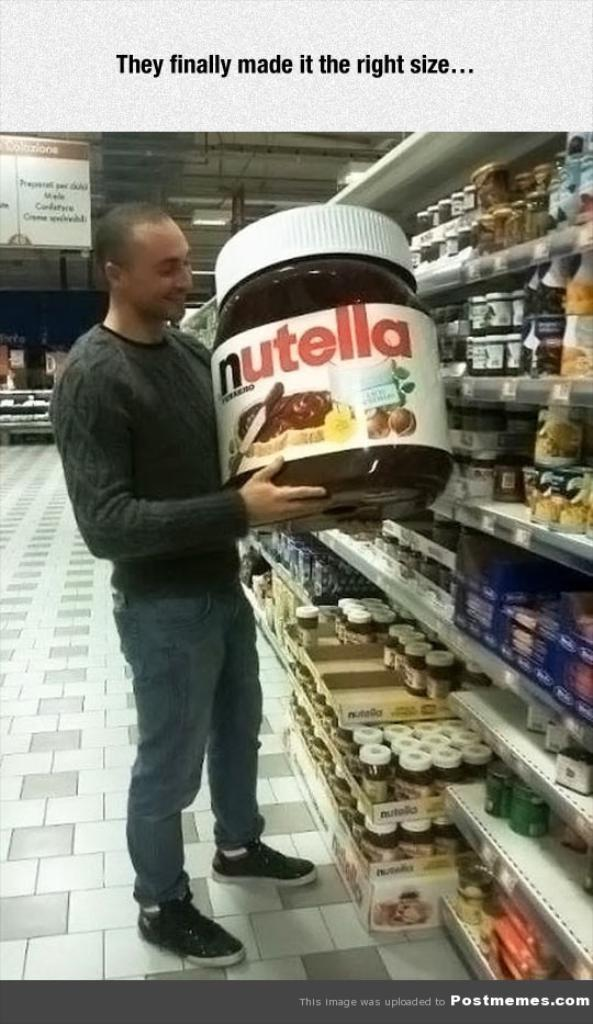Provide a one-sentence caption for the provided image. A man in a store is holding a giant bottle of Nutella. 